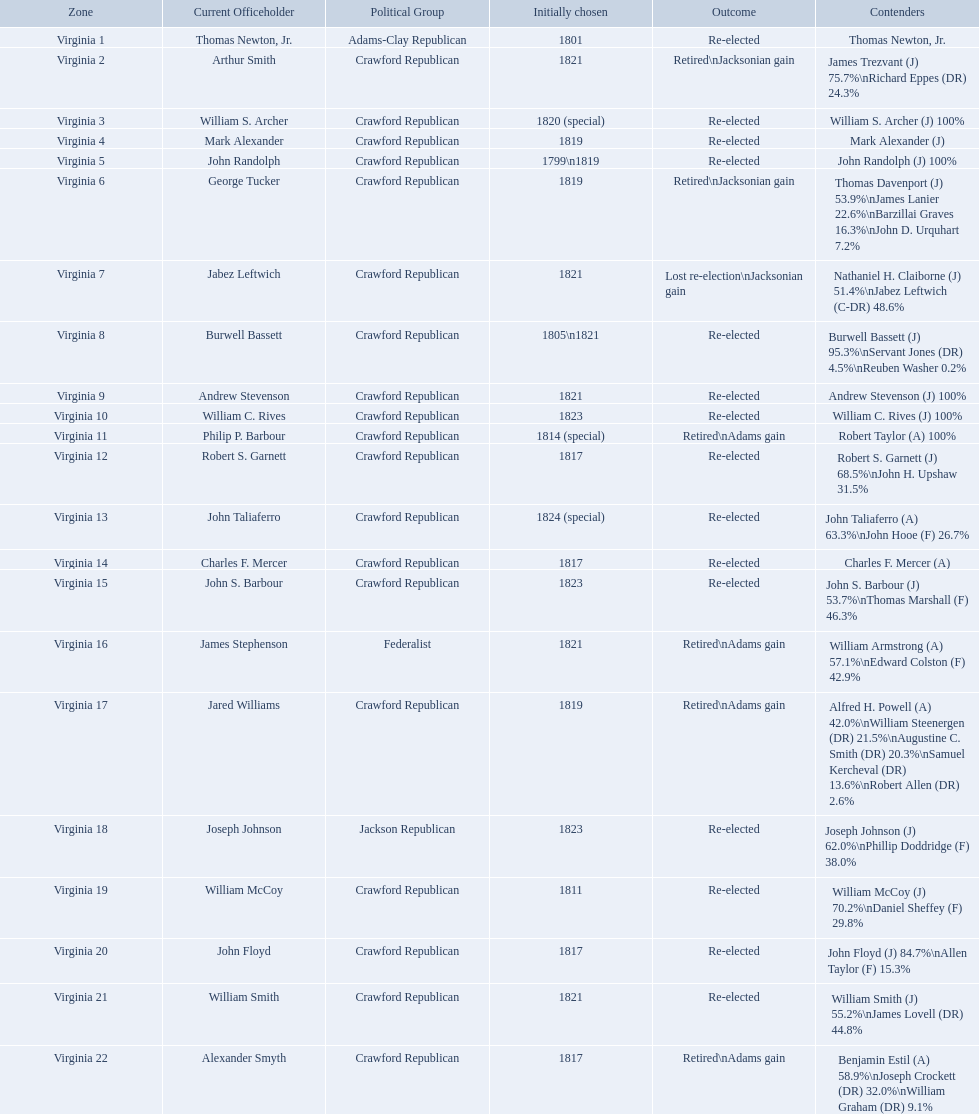What party is a crawford republican? Crawford Republican, Crawford Republican, Crawford Republican, Crawford Republican, Crawford Republican, Crawford Republican, Crawford Republican, Crawford Republican, Crawford Republican, Crawford Republican, Crawford Republican, Crawford Republican, Crawford Republican, Crawford Republican, Crawford Republican, Crawford Republican, Crawford Republican, Crawford Republican, Crawford Republican. What candidates have over 76%? James Trezvant (J) 75.7%\nRichard Eppes (DR) 24.3%, William S. Archer (J) 100%, John Randolph (J) 100%, Burwell Bassett (J) 95.3%\nServant Jones (DR) 4.5%\nReuben Washer 0.2%, Andrew Stevenson (J) 100%, William C. Rives (J) 100%, Robert Taylor (A) 100%, John Floyd (J) 84.7%\nAllen Taylor (F) 15.3%. Which result was retired jacksonian gain? Retired\nJacksonian gain. Who was the incumbent? Arthur Smith. 